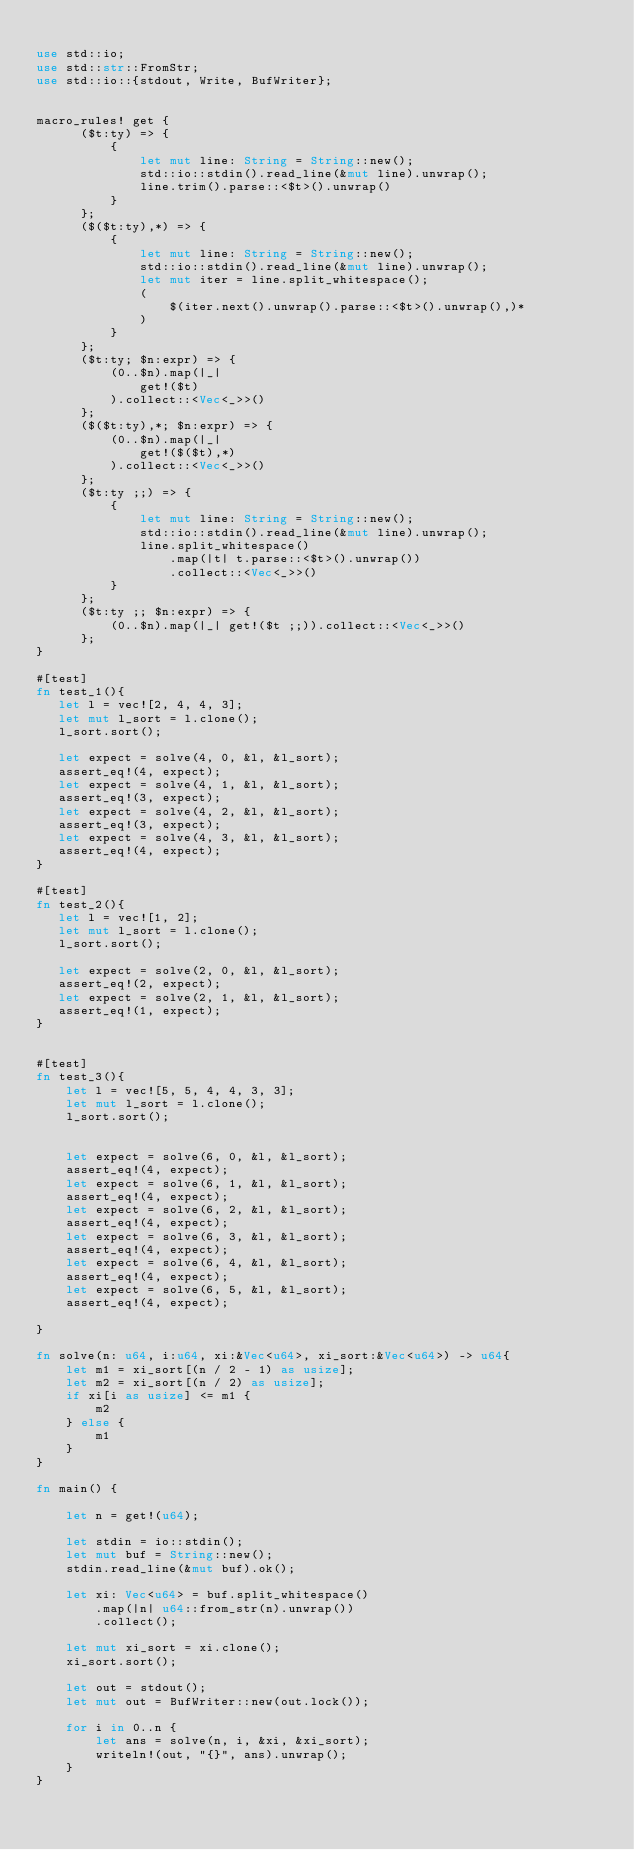Convert code to text. <code><loc_0><loc_0><loc_500><loc_500><_Rust_>
use std::io;
use std::str::FromStr;
use std::io::{stdout, Write, BufWriter};


macro_rules! get {
      ($t:ty) => {
          {
              let mut line: String = String::new();
              std::io::stdin().read_line(&mut line).unwrap();
              line.trim().parse::<$t>().unwrap()
          }
      };
      ($($t:ty),*) => {
          {
              let mut line: String = String::new();
              std::io::stdin().read_line(&mut line).unwrap();
              let mut iter = line.split_whitespace();
              (
                  $(iter.next().unwrap().parse::<$t>().unwrap(),)*
              )
          }
      };
      ($t:ty; $n:expr) => {
          (0..$n).map(|_|
              get!($t)
          ).collect::<Vec<_>>()
      };
      ($($t:ty),*; $n:expr) => {
          (0..$n).map(|_|
              get!($($t),*)
          ).collect::<Vec<_>>()
      };
      ($t:ty ;;) => {
          {
              let mut line: String = String::new();
              std::io::stdin().read_line(&mut line).unwrap();
              line.split_whitespace()
                  .map(|t| t.parse::<$t>().unwrap())
                  .collect::<Vec<_>>()
          }
      };
      ($t:ty ;; $n:expr) => {
          (0..$n).map(|_| get!($t ;;)).collect::<Vec<_>>()
      };
}

#[test]
fn test_1(){
   let l = vec![2, 4, 4, 3];
   let mut l_sort = l.clone();
   l_sort.sort();

   let expect = solve(4, 0, &l, &l_sort);
   assert_eq!(4, expect);
   let expect = solve(4, 1, &l, &l_sort);
   assert_eq!(3, expect);
   let expect = solve(4, 2, &l, &l_sort);
   assert_eq!(3, expect);
   let expect = solve(4, 3, &l, &l_sort);
   assert_eq!(4, expect);
}

#[test]
fn test_2(){
   let l = vec![1, 2];
   let mut l_sort = l.clone();
   l_sort.sort();

   let expect = solve(2, 0, &l, &l_sort);
   assert_eq!(2, expect);
   let expect = solve(2, 1, &l, &l_sort);
   assert_eq!(1, expect);
}


#[test]
fn test_3(){
    let l = vec![5, 5, 4, 4, 3, 3];
    let mut l_sort = l.clone();
    l_sort.sort();


    let expect = solve(6, 0, &l, &l_sort);
    assert_eq!(4, expect);   
    let expect = solve(6, 1, &l, &l_sort);
    assert_eq!(4, expect);
    let expect = solve(6, 2, &l, &l_sort);
    assert_eq!(4, expect);
    let expect = solve(6, 3, &l, &l_sort);
    assert_eq!(4, expect);
    let expect = solve(6, 4, &l, &l_sort);
    assert_eq!(4, expect);
    let expect = solve(6, 5, &l, &l_sort);
    assert_eq!(4, expect);

}

fn solve(n: u64, i:u64, xi:&Vec<u64>, xi_sort:&Vec<u64>) -> u64{
    let m1 = xi_sort[(n / 2 - 1) as usize];
    let m2 = xi_sort[(n / 2) as usize];
    if xi[i as usize] <= m1 {
        m2
    } else {
        m1
    }
}

fn main() {

    let n = get!(u64);
    
    let stdin = io::stdin();
    let mut buf = String::new();
    stdin.read_line(&mut buf).ok();

    let xi: Vec<u64> = buf.split_whitespace()
        .map(|n| u64::from_str(n).unwrap())
        .collect();

    let mut xi_sort = xi.clone();
    xi_sort.sort();

    let out = stdout();
    let mut out = BufWriter::new(out.lock());
    
    for i in 0..n {
        let ans = solve(n, i, &xi, &xi_sort);
        writeln!(out, "{}", ans).unwrap();   
    }
}
</code> 